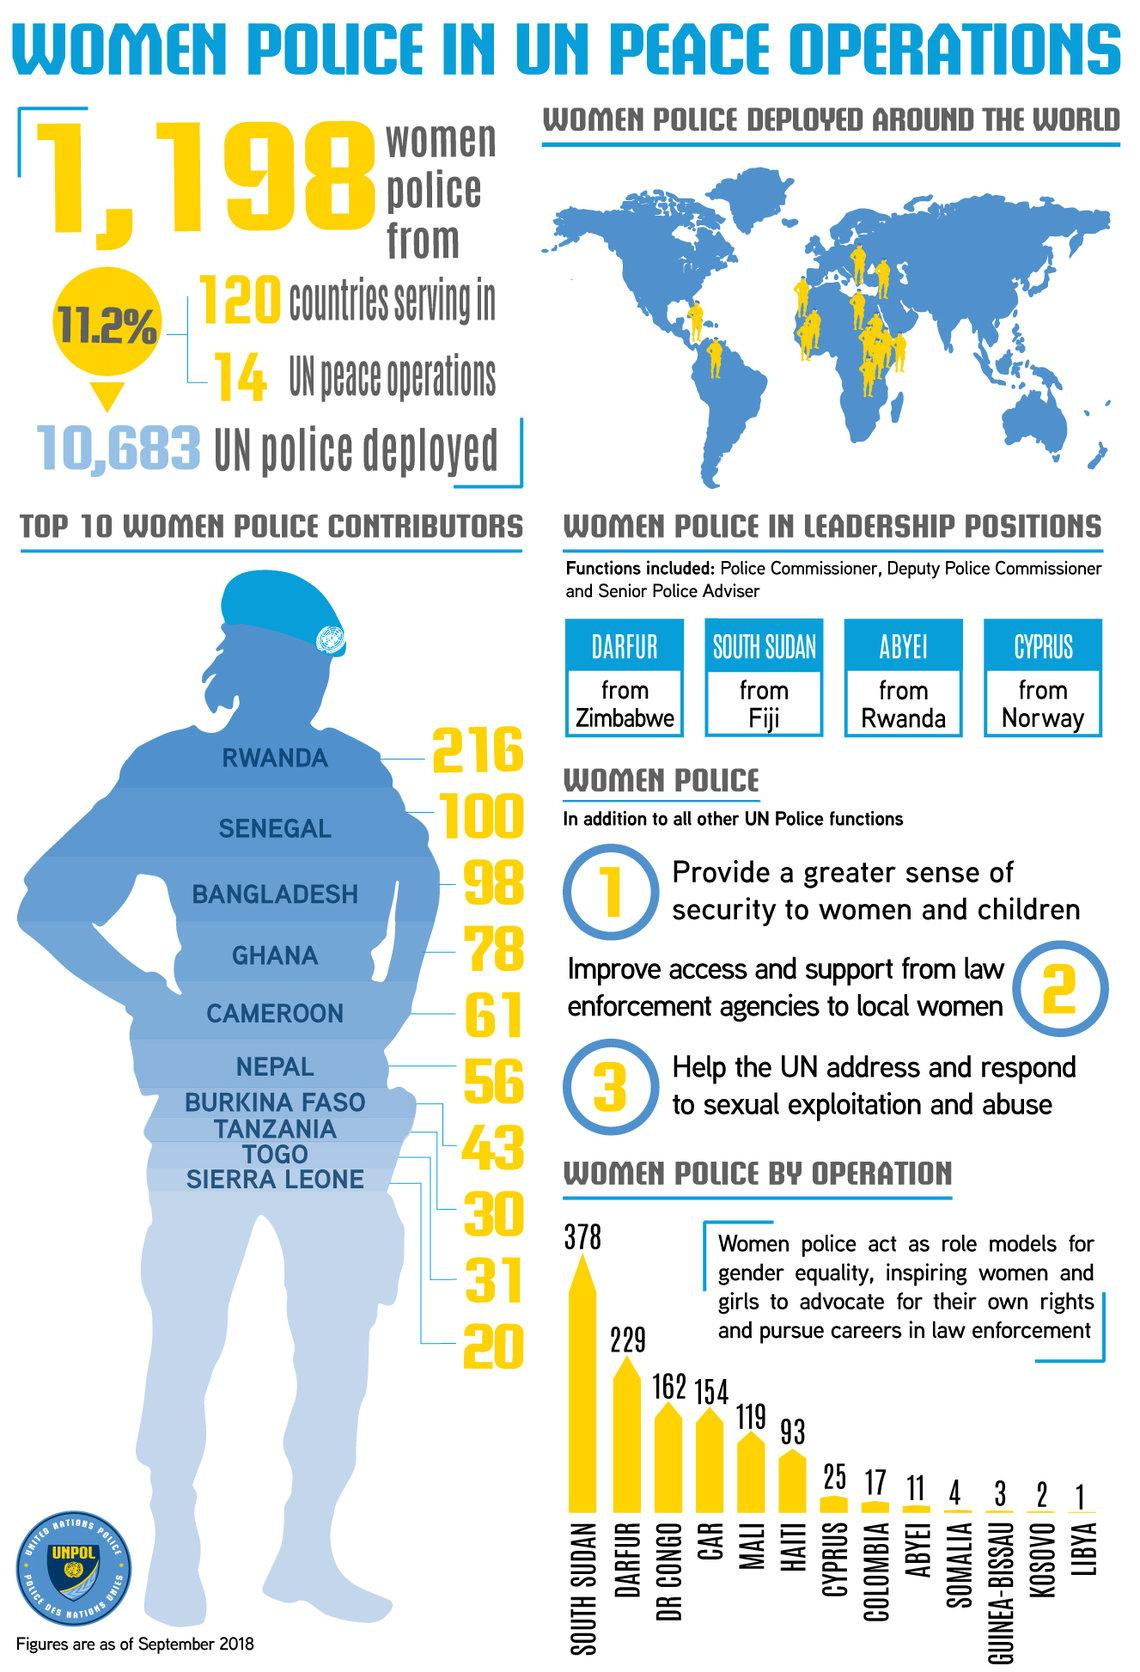Identify some key points in this picture. According to the data provided, Rwanda and Senegal have contributed a total of 316 women police to the UN peacekeeping operations. The country with the second highest number of women police officers is Darfur. Cameroon is ranked fifth among the top 10 countries with the most female police contributors. There are 139 female police officers contributed by Ghana and Cameroon. Togo is ranked ninth among the top 10 countries with the highest number of female police contributors. 